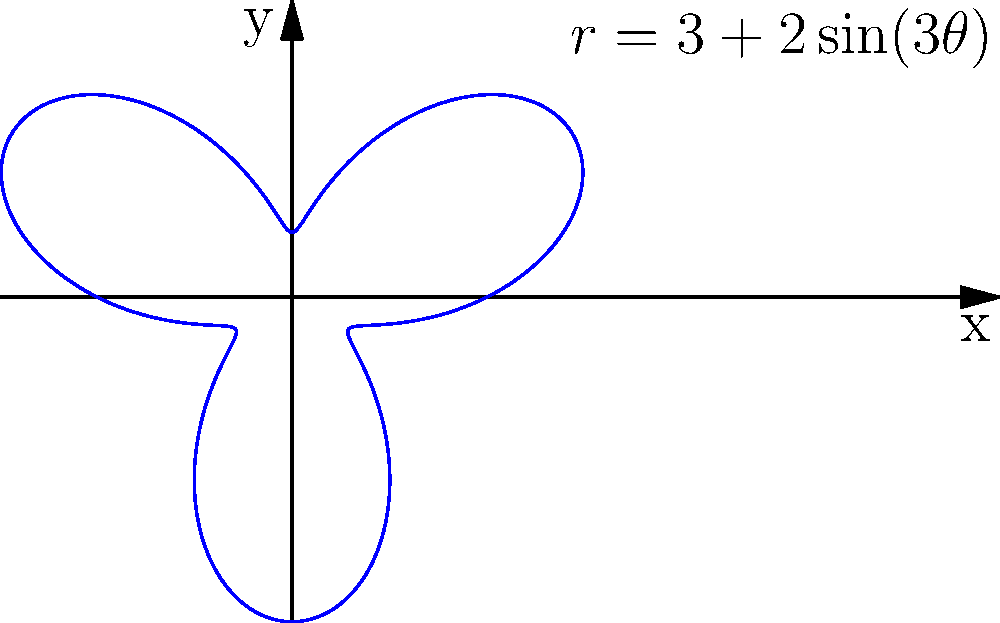As a farmer, you've acquired an irregularly shaped piece of land. The boundary of this land can be described in polar coordinates by the equation $r = 3 + 2\sin(3\theta)$, where $r$ is in acres and $\theta$ is in radians. Calculate the total area of this farmland. To calculate the area of this irregularly shaped farmland using polar coordinates, we'll follow these steps:

1) The formula for the area of a region in polar coordinates is:

   $$A = \frac{1}{2} \int_0^{2\pi} r^2(\theta) d\theta$$

2) In this case, $r(\theta) = 3 + 2\sin(3\theta)$. We need to square this:

   $$r^2(\theta) = (3 + 2\sin(3\theta))^2 = 9 + 12\sin(3\theta) + 4\sin^2(3\theta)$$

3) Now, let's set up the integral:

   $$A = \frac{1}{2} \int_0^{2\pi} (9 + 12\sin(3\theta) + 4\sin^2(3\theta)) d\theta$$

4) Let's integrate each term separately:

   a) $\int_0^{2\pi} 9 d\theta = 9\theta \big|_0^{2\pi} = 18\pi$

   b) $\int_0^{2\pi} 12\sin(3\theta) d\theta = -4\cos(3\theta) \big|_0^{2\pi} = 0$

   c) For the $\sin^2$ term, we can use the identity $\sin^2(x) = \frac{1}{2}(1 - \cos(2x))$:
      
      $\int_0^{2\pi} 4\sin^2(3\theta) d\theta = \int_0^{2\pi} 2(1 - \cos(6\theta)) d\theta$
      $= 2\theta - \frac{1}{3}\sin(6\theta) \big|_0^{2\pi} = 4\pi$

5) Adding these up and multiplying by $\frac{1}{2}$:

   $$A = \frac{1}{2}(18\pi + 0 + 4\pi) = 11\pi$$

Therefore, the total area of the farmland is $11\pi$ square acres.
Answer: $11\pi$ square acres 